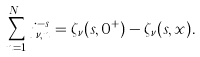Convert formula to latex. <formula><loc_0><loc_0><loc_500><loc_500>\sum _ { n = 1 } ^ { N _ { \nu } } j _ { \nu , n } ^ { - s } = \zeta _ { \nu } ( s , 0 ^ { + } ) - \zeta _ { \nu } ( s , x ) .</formula> 